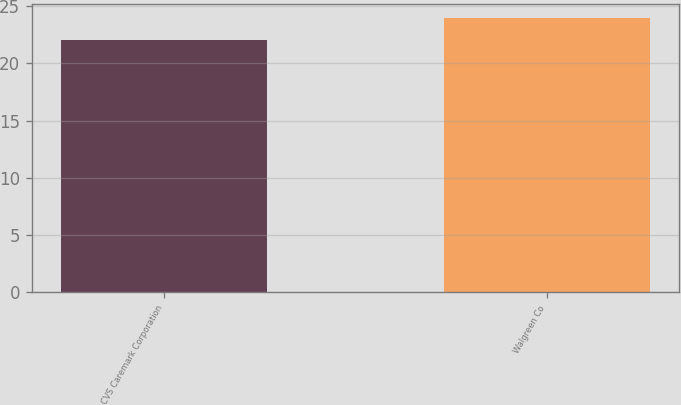Convert chart to OTSL. <chart><loc_0><loc_0><loc_500><loc_500><bar_chart><fcel>CVS Caremark Corporation<fcel>Walgreen Co<nl><fcel>22<fcel>24<nl></chart> 